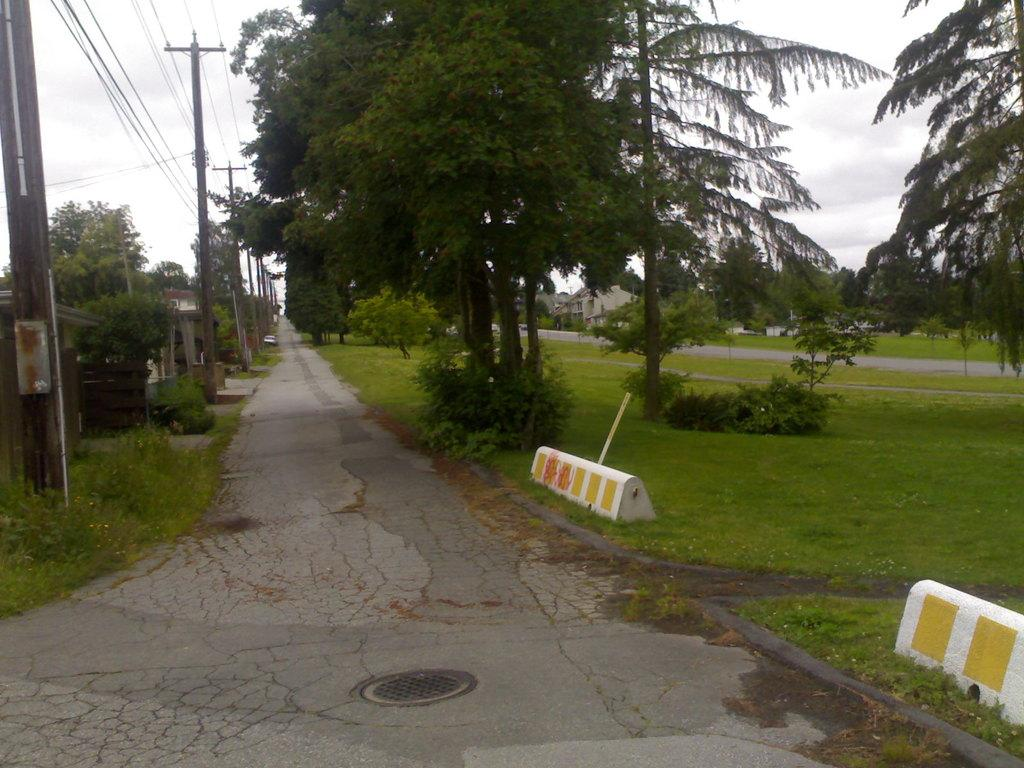What is the main feature of the image? There is a walkway in the image. What can be seen on the left side of the walkway? Electric poles and wires are on the left side of the walkway. What type of vegetation is present on either side of the walkway? There are trees on either side of the walkway. What type of structures are visible on either side of the walkway? There are buildings on either side of the walkway. What type of cloth is being used to pump water in the image? There is no cloth or water pump present in the image. What type of print can be seen on the trees in the image? There is no print on the trees in the image; they are natural trees. 